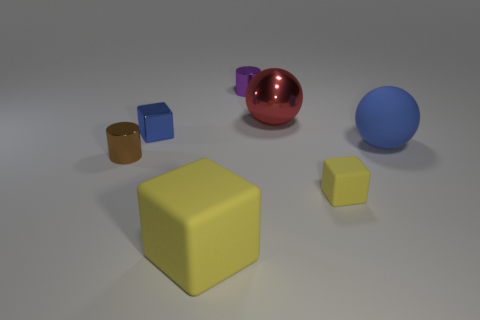How would you describe the atmosphere or mood of this scene with various colorful objects? The scene conveys a simple and quiet mood, with a clean and uncluttered composition. The use of soft lighting and the array of geometric shapes in pastel and primary colors set a calm and study-like atmosphere, perhaps reminiscent of a basic 3D modeling environment or an elementary educational setting. 